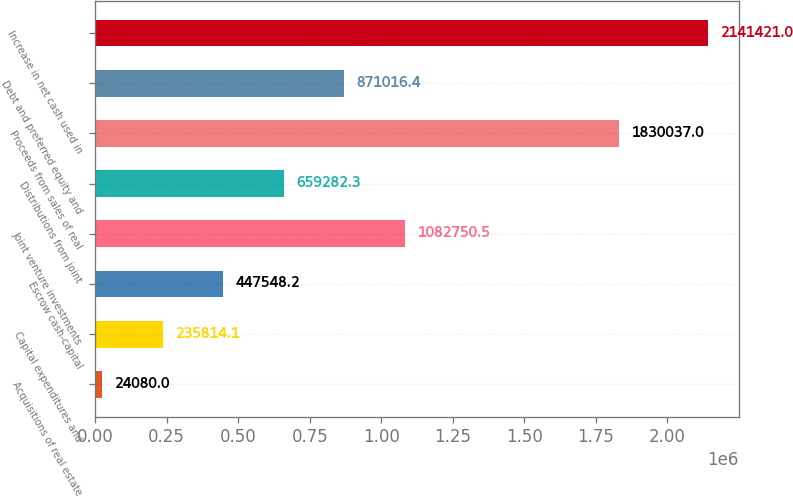<chart> <loc_0><loc_0><loc_500><loc_500><bar_chart><fcel>Acquisitions of real estate<fcel>Capital expenditures and<fcel>Escrow cash-capital<fcel>Joint venture investments<fcel>Distributions from joint<fcel>Proceeds from sales of real<fcel>Debt and preferred equity and<fcel>Increase in net cash used in<nl><fcel>24080<fcel>235814<fcel>447548<fcel>1.08275e+06<fcel>659282<fcel>1.83004e+06<fcel>871016<fcel>2.14142e+06<nl></chart> 